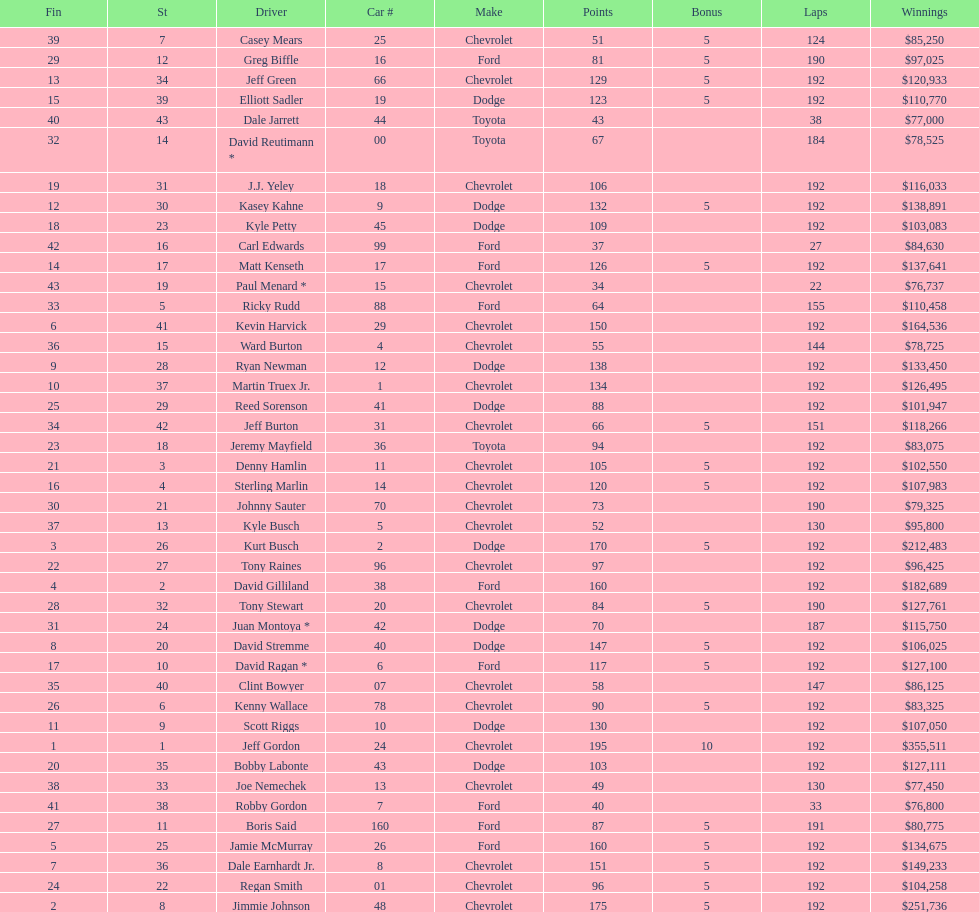I'm looking to parse the entire table for insights. Could you assist me with that? {'header': ['Fin', 'St', 'Driver', 'Car #', 'Make', 'Points', 'Bonus', 'Laps', 'Winnings'], 'rows': [['39', '7', 'Casey Mears', '25', 'Chevrolet', '51', '5', '124', '$85,250'], ['29', '12', 'Greg Biffle', '16', 'Ford', '81', '5', '190', '$97,025'], ['13', '34', 'Jeff Green', '66', 'Chevrolet', '129', '5', '192', '$120,933'], ['15', '39', 'Elliott Sadler', '19', 'Dodge', '123', '5', '192', '$110,770'], ['40', '43', 'Dale Jarrett', '44', 'Toyota', '43', '', '38', '$77,000'], ['32', '14', 'David Reutimann *', '00', 'Toyota', '67', '', '184', '$78,525'], ['19', '31', 'J.J. Yeley', '18', 'Chevrolet', '106', '', '192', '$116,033'], ['12', '30', 'Kasey Kahne', '9', 'Dodge', '132', '5', '192', '$138,891'], ['18', '23', 'Kyle Petty', '45', 'Dodge', '109', '', '192', '$103,083'], ['42', '16', 'Carl Edwards', '99', 'Ford', '37', '', '27', '$84,630'], ['14', '17', 'Matt Kenseth', '17', 'Ford', '126', '5', '192', '$137,641'], ['43', '19', 'Paul Menard *', '15', 'Chevrolet', '34', '', '22', '$76,737'], ['33', '5', 'Ricky Rudd', '88', 'Ford', '64', '', '155', '$110,458'], ['6', '41', 'Kevin Harvick', '29', 'Chevrolet', '150', '', '192', '$164,536'], ['36', '15', 'Ward Burton', '4', 'Chevrolet', '55', '', '144', '$78,725'], ['9', '28', 'Ryan Newman', '12', 'Dodge', '138', '', '192', '$133,450'], ['10', '37', 'Martin Truex Jr.', '1', 'Chevrolet', '134', '', '192', '$126,495'], ['25', '29', 'Reed Sorenson', '41', 'Dodge', '88', '', '192', '$101,947'], ['34', '42', 'Jeff Burton', '31', 'Chevrolet', '66', '5', '151', '$118,266'], ['23', '18', 'Jeremy Mayfield', '36', 'Toyota', '94', '', '192', '$83,075'], ['21', '3', 'Denny Hamlin', '11', 'Chevrolet', '105', '5', '192', '$102,550'], ['16', '4', 'Sterling Marlin', '14', 'Chevrolet', '120', '5', '192', '$107,983'], ['30', '21', 'Johnny Sauter', '70', 'Chevrolet', '73', '', '190', '$79,325'], ['37', '13', 'Kyle Busch', '5', 'Chevrolet', '52', '', '130', '$95,800'], ['3', '26', 'Kurt Busch', '2', 'Dodge', '170', '5', '192', '$212,483'], ['22', '27', 'Tony Raines', '96', 'Chevrolet', '97', '', '192', '$96,425'], ['4', '2', 'David Gilliland', '38', 'Ford', '160', '', '192', '$182,689'], ['28', '32', 'Tony Stewart', '20', 'Chevrolet', '84', '5', '190', '$127,761'], ['31', '24', 'Juan Montoya *', '42', 'Dodge', '70', '', '187', '$115,750'], ['8', '20', 'David Stremme', '40', 'Dodge', '147', '5', '192', '$106,025'], ['17', '10', 'David Ragan *', '6', 'Ford', '117', '5', '192', '$127,100'], ['35', '40', 'Clint Bowyer', '07', 'Chevrolet', '58', '', '147', '$86,125'], ['26', '6', 'Kenny Wallace', '78', 'Chevrolet', '90', '5', '192', '$83,325'], ['11', '9', 'Scott Riggs', '10', 'Dodge', '130', '', '192', '$107,050'], ['1', '1', 'Jeff Gordon', '24', 'Chevrolet', '195', '10', '192', '$355,511'], ['20', '35', 'Bobby Labonte', '43', 'Dodge', '103', '', '192', '$127,111'], ['38', '33', 'Joe Nemechek', '13', 'Chevrolet', '49', '', '130', '$77,450'], ['41', '38', 'Robby Gordon', '7', 'Ford', '40', '', '33', '$76,800'], ['27', '11', 'Boris Said', '160', 'Ford', '87', '5', '191', '$80,775'], ['5', '25', 'Jamie McMurray', '26', 'Ford', '160', '5', '192', '$134,675'], ['7', '36', 'Dale Earnhardt Jr.', '8', 'Chevrolet', '151', '5', '192', '$149,233'], ['24', '22', 'Regan Smith', '01', 'Chevrolet', '96', '5', '192', '$104,258'], ['2', '8', 'Jimmie Johnson', '48', 'Chevrolet', '175', '5', '192', '$251,736']]} How many drivers earned no bonus for this race? 23. 